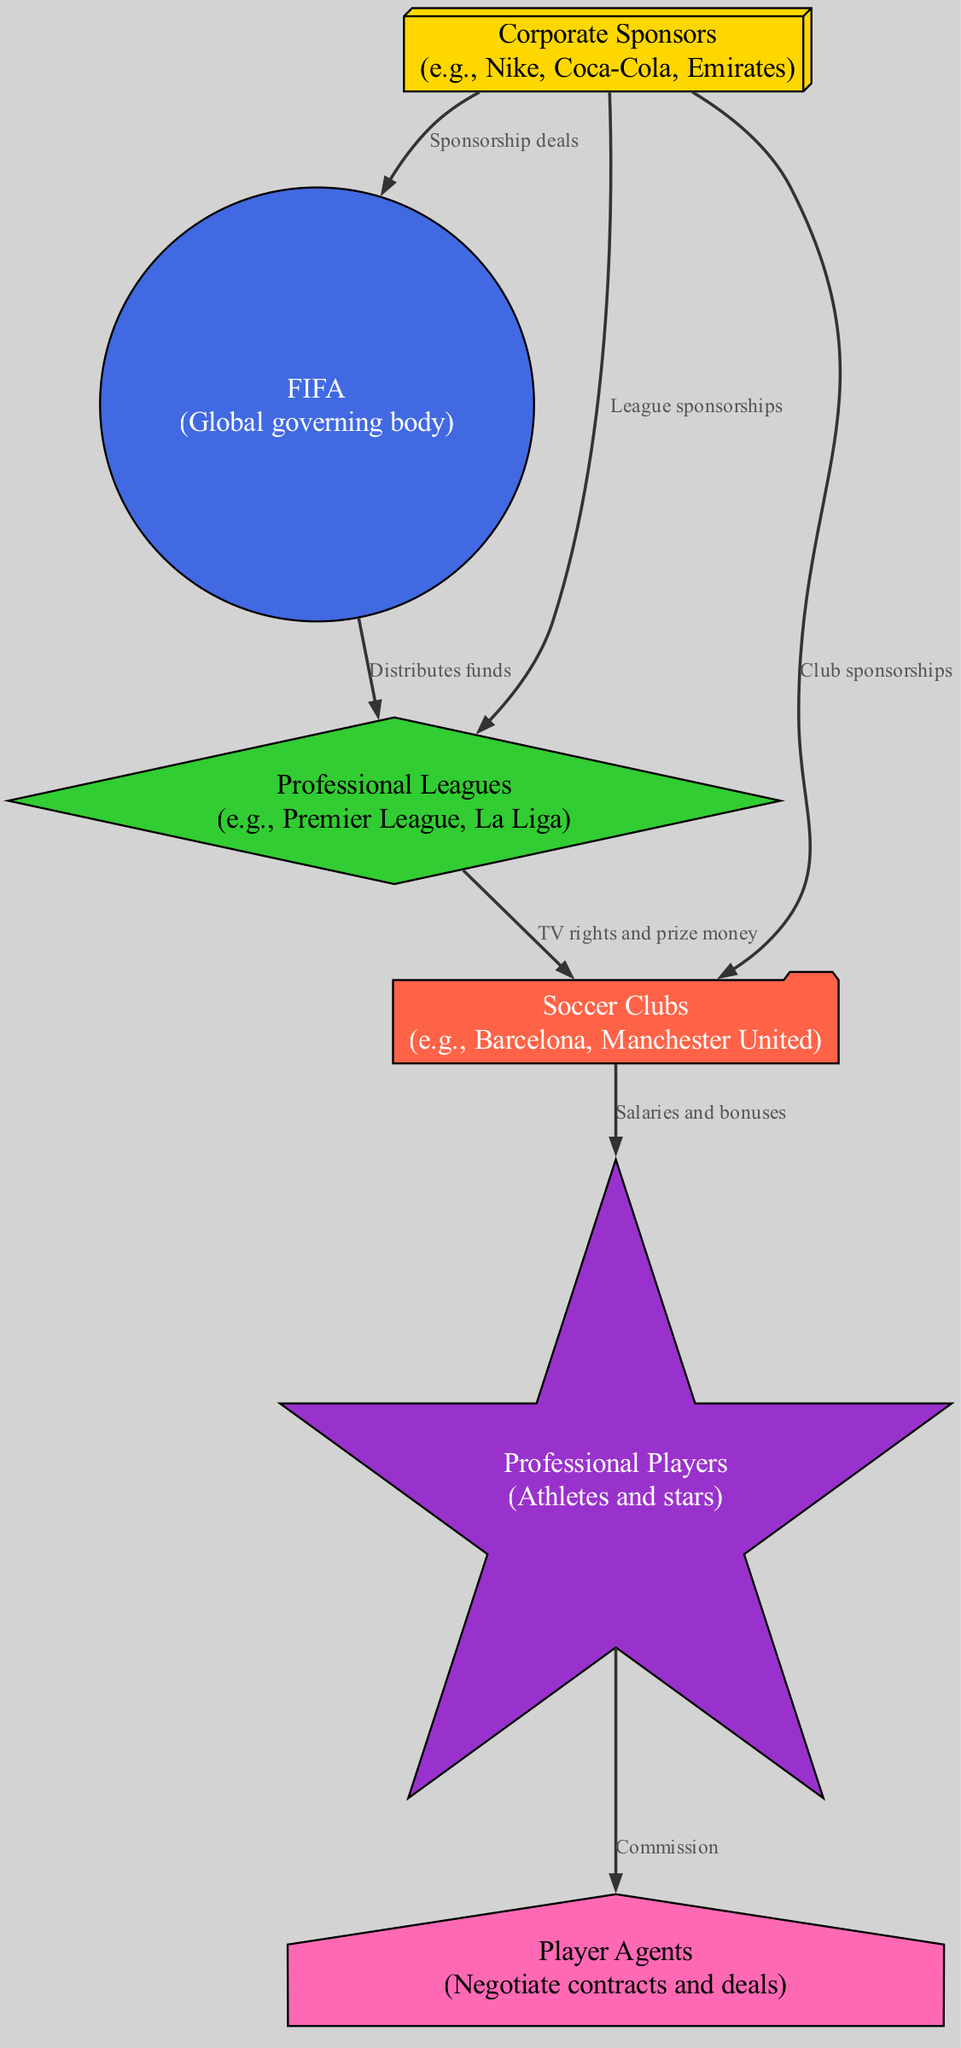What are the types of nodes in the diagram? The diagram contains six types of nodes: Corporate Sponsors, FIFA, Professional Leagues, Soccer Clubs, Professional Players, and Player Agents. Each type represents a specific entity involved in the flow of money in professional soccer.
Answer: Corporate Sponsors, FIFA, Professional Leagues, Soccer Clubs, Professional Players, Player Agents How many edges are present in the diagram? The diagram has six edges, which represent the connections and flow of money between the nodes. Each edge signifies a specific relationship between two entities in the soccer money flow.
Answer: 6 What do Corporate Sponsors provide to FIFA? According to the diagram, Corporate Sponsors provide sponsorship deals to FIFA, which indicates a financial support relationship. This highlights the influence of sponsors at the governing body level in soccer.
Answer: Sponsorship deals What is the relationship between Leagues and Clubs? The diagram shows that Leagues distribute funds such as TV rights and prize money to Clubs. This indicates a crucial financial connection that helps sustain the operations of soccer clubs at the league level.
Answer: TV rights and prize money Who gets a commission from the players? The diagram indicates that Player Agents receive a commission from Professional Players. This represents the financial dealings that occur between players and their agents within the sport.
Answer: Player Agents What node receives money from both Sponsors and FIFA? The Professional Leagues node receives money from both Corporate Sponsors and FIFA. Corporate Sponsors provide league sponsorships while FIFA distributes funds to leagues, making this node an essential intermediary.
Answer: Professional Leagues Which node sends salaries and bonuses to players? Soccer Clubs are indicated as the node that provides salaries and bonuses to Professional Players, demonstrating the flow of money from clubs to the athletes who play for them.
Answer: Soccer Clubs How does the money flow from Sponsors to Players? The money flows from Corporate Sponsors to FIFA through sponsorship deals, then to Professional Leagues who distribute funds to Clubs. Finally, Clubs provide salaries and bonuses to Professional Players. This highlights the multi-tiered financial system in professional soccer.
Answer: Corporate Sponsors → FIFA → Leagues → Clubs → Players What type of deal is made between players and agents? The diagram states that Professional Players have a relationship with Player Agents where commissions are involved. This indicates a financial agreement concerning the athletes' contracts and negotiations.
Answer: Commission 